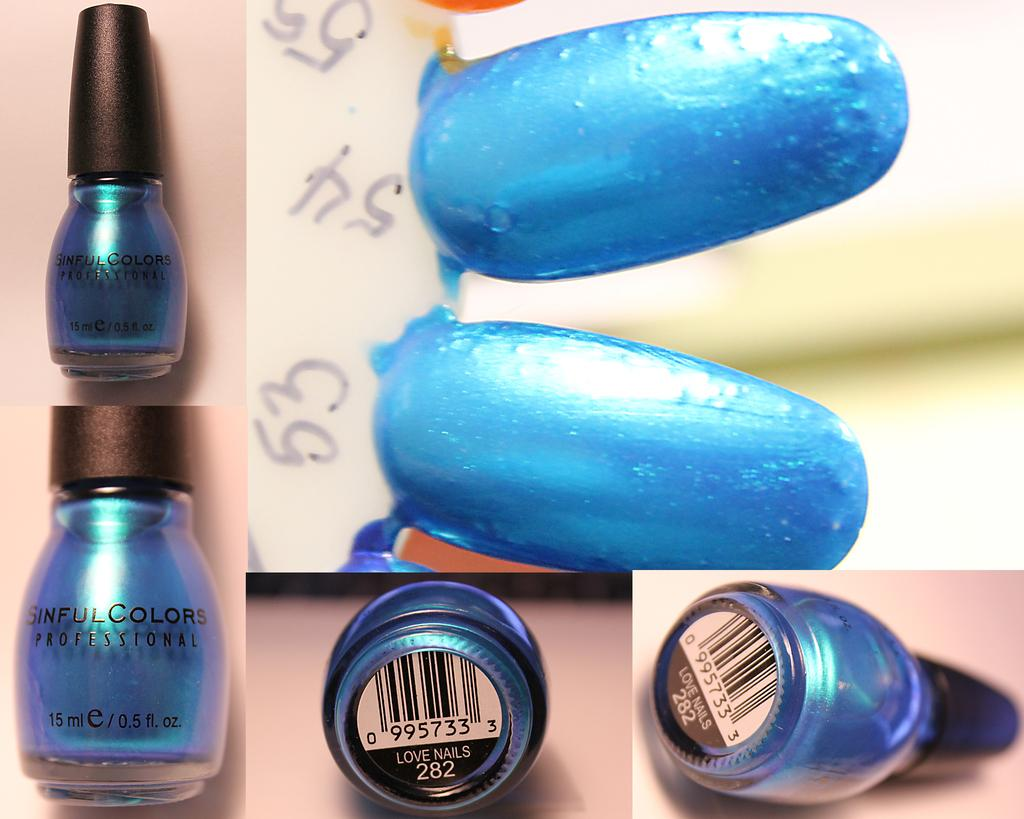<image>
Summarize the visual content of the image. A bottle of blue fingernail polish from Sinful Colors Professional 